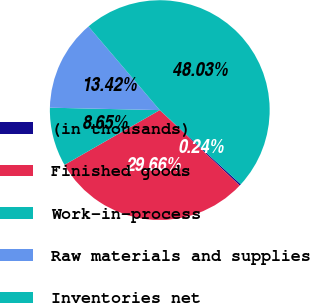Convert chart. <chart><loc_0><loc_0><loc_500><loc_500><pie_chart><fcel>(in thousands)<fcel>Finished goods<fcel>Work-in-process<fcel>Raw materials and supplies<fcel>Inventories net<nl><fcel>0.24%<fcel>29.66%<fcel>8.65%<fcel>13.42%<fcel>48.03%<nl></chart> 